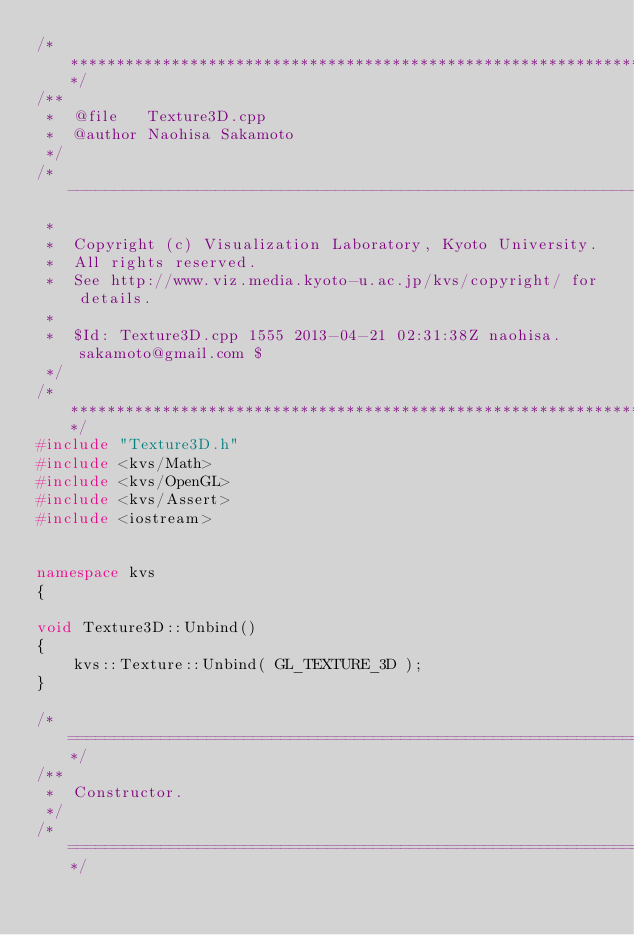Convert code to text. <code><loc_0><loc_0><loc_500><loc_500><_C++_>/****************************************************************************/
/**
 *  @file   Texture3D.cpp
 *  @author Naohisa Sakamoto
 */
/*----------------------------------------------------------------------------
 *
 *  Copyright (c) Visualization Laboratory, Kyoto University.
 *  All rights reserved.
 *  See http://www.viz.media.kyoto-u.ac.jp/kvs/copyright/ for details.
 *
 *  $Id: Texture3D.cpp 1555 2013-04-21 02:31:38Z naohisa.sakamoto@gmail.com $
 */
/****************************************************************************/
#include "Texture3D.h"
#include <kvs/Math>
#include <kvs/OpenGL>
#include <kvs/Assert>
#include <iostream>


namespace kvs
{

void Texture3D::Unbind()
{
    kvs::Texture::Unbind( GL_TEXTURE_3D );
}

/*==========================================================================*/
/**
 *  Constructor.
 */
/*==========================================================================*/</code> 